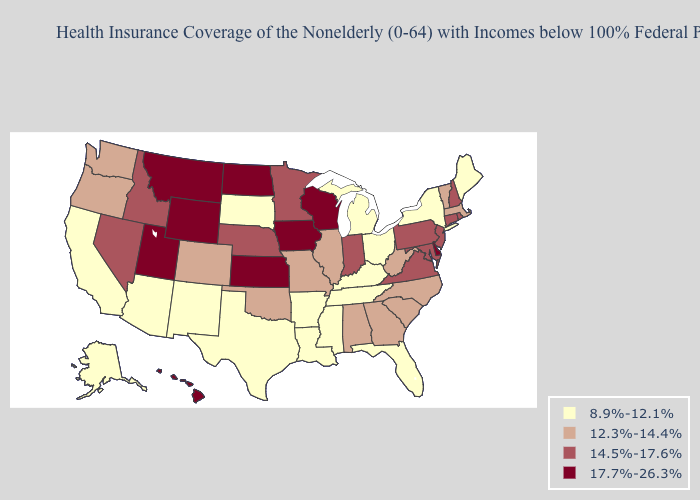What is the lowest value in the USA?
Give a very brief answer. 8.9%-12.1%. What is the highest value in the South ?
Short answer required. 17.7%-26.3%. Among the states that border Washington , which have the lowest value?
Short answer required. Oregon. What is the highest value in the South ?
Concise answer only. 17.7%-26.3%. Name the states that have a value in the range 12.3%-14.4%?
Short answer required. Alabama, Colorado, Georgia, Illinois, Massachusetts, Missouri, North Carolina, Oklahoma, Oregon, South Carolina, Vermont, Washington, West Virginia. Does the first symbol in the legend represent the smallest category?
Be succinct. Yes. Name the states that have a value in the range 8.9%-12.1%?
Give a very brief answer. Alaska, Arizona, Arkansas, California, Florida, Kentucky, Louisiana, Maine, Michigan, Mississippi, New Mexico, New York, Ohio, South Dakota, Tennessee, Texas. What is the lowest value in the USA?
Concise answer only. 8.9%-12.1%. Does the first symbol in the legend represent the smallest category?
Answer briefly. Yes. Name the states that have a value in the range 8.9%-12.1%?
Be succinct. Alaska, Arizona, Arkansas, California, Florida, Kentucky, Louisiana, Maine, Michigan, Mississippi, New Mexico, New York, Ohio, South Dakota, Tennessee, Texas. Does Massachusetts have a higher value than Illinois?
Quick response, please. No. Which states hav the highest value in the Northeast?
Concise answer only. Connecticut, New Hampshire, New Jersey, Pennsylvania, Rhode Island. What is the value of Kentucky?
Answer briefly. 8.9%-12.1%. Does Maryland have a lower value than Iowa?
Concise answer only. Yes. Which states have the highest value in the USA?
Keep it brief. Delaware, Hawaii, Iowa, Kansas, Montana, North Dakota, Utah, Wisconsin, Wyoming. 